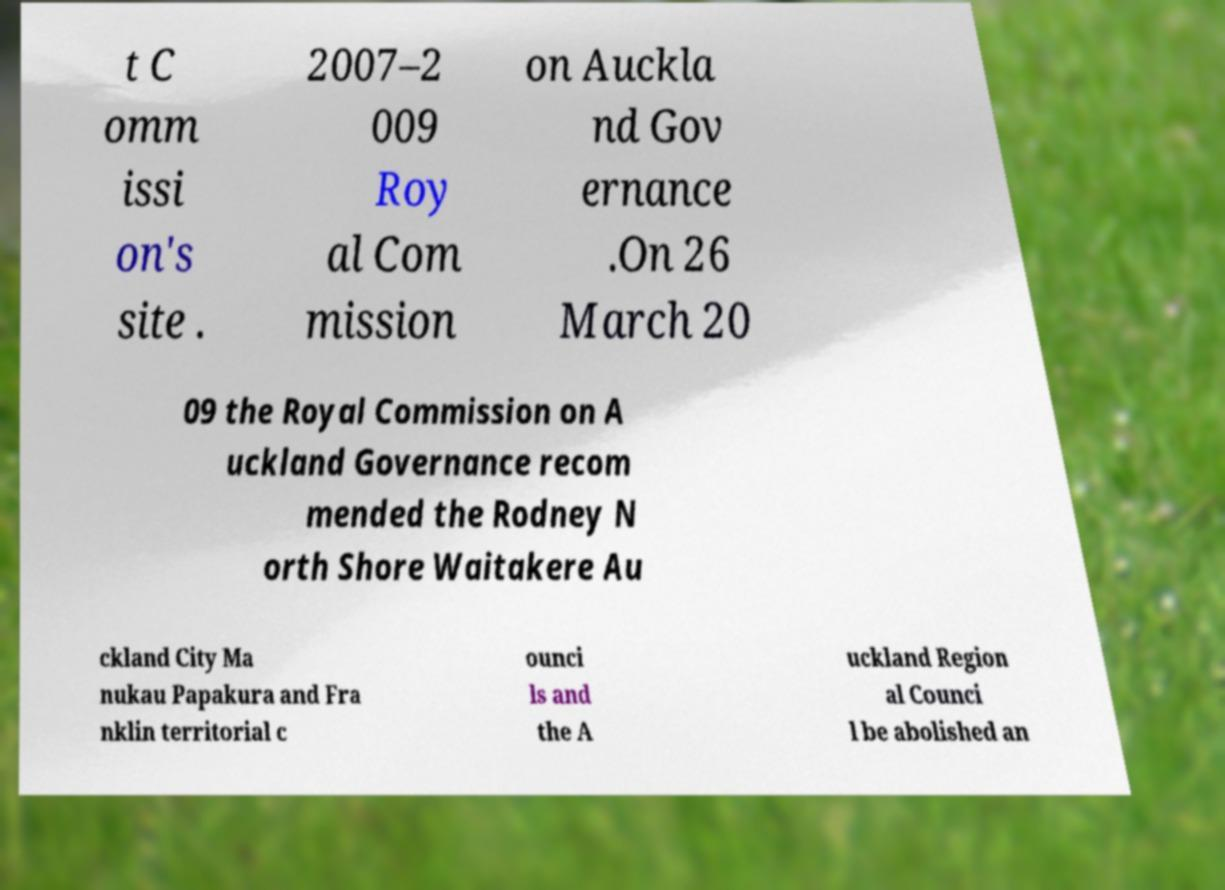Please read and relay the text visible in this image. What does it say? t C omm issi on's site . 2007–2 009 Roy al Com mission on Auckla nd Gov ernance .On 26 March 20 09 the Royal Commission on A uckland Governance recom mended the Rodney N orth Shore Waitakere Au ckland City Ma nukau Papakura and Fra nklin territorial c ounci ls and the A uckland Region al Counci l be abolished an 